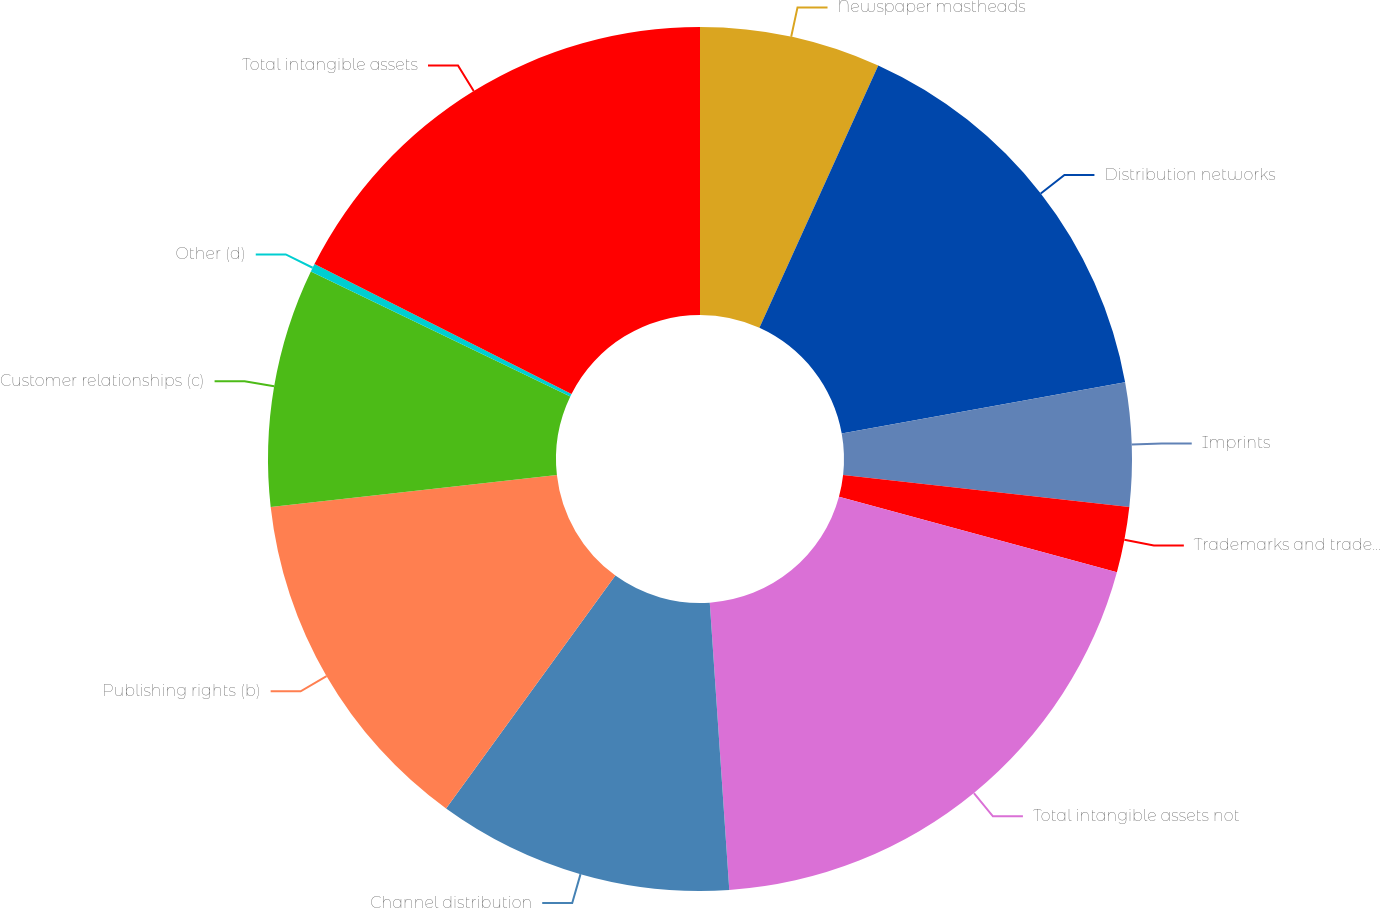Convert chart to OTSL. <chart><loc_0><loc_0><loc_500><loc_500><pie_chart><fcel>Newspaper mastheads<fcel>Distribution networks<fcel>Imprints<fcel>Trademarks and tradenames<fcel>Total intangible assets not<fcel>Channel distribution<fcel>Publishing rights (b)<fcel>Customer relationships (c)<fcel>Other (d)<fcel>Total intangible assets<nl><fcel>6.77%<fcel>15.39%<fcel>4.61%<fcel>2.45%<fcel>19.7%<fcel>11.08%<fcel>13.23%<fcel>8.92%<fcel>0.3%<fcel>17.55%<nl></chart> 